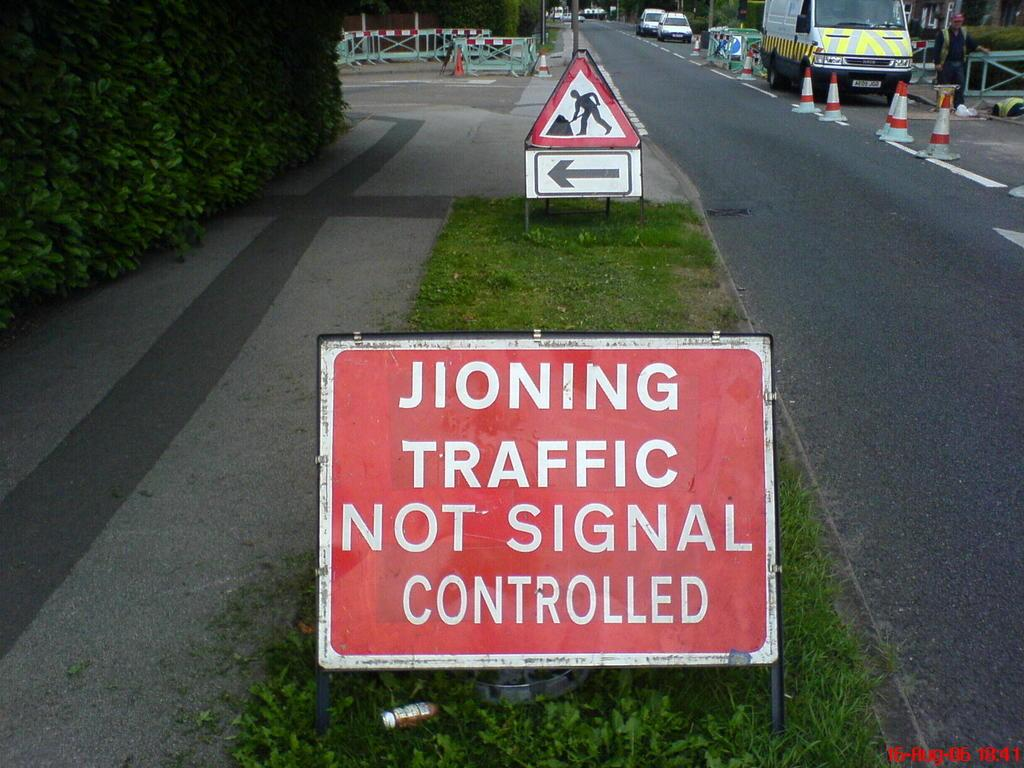<image>
Give a short and clear explanation of the subsequent image. A road containing roadworks and a sign which is mispelled concerning "JIONING TRAFFIC". 